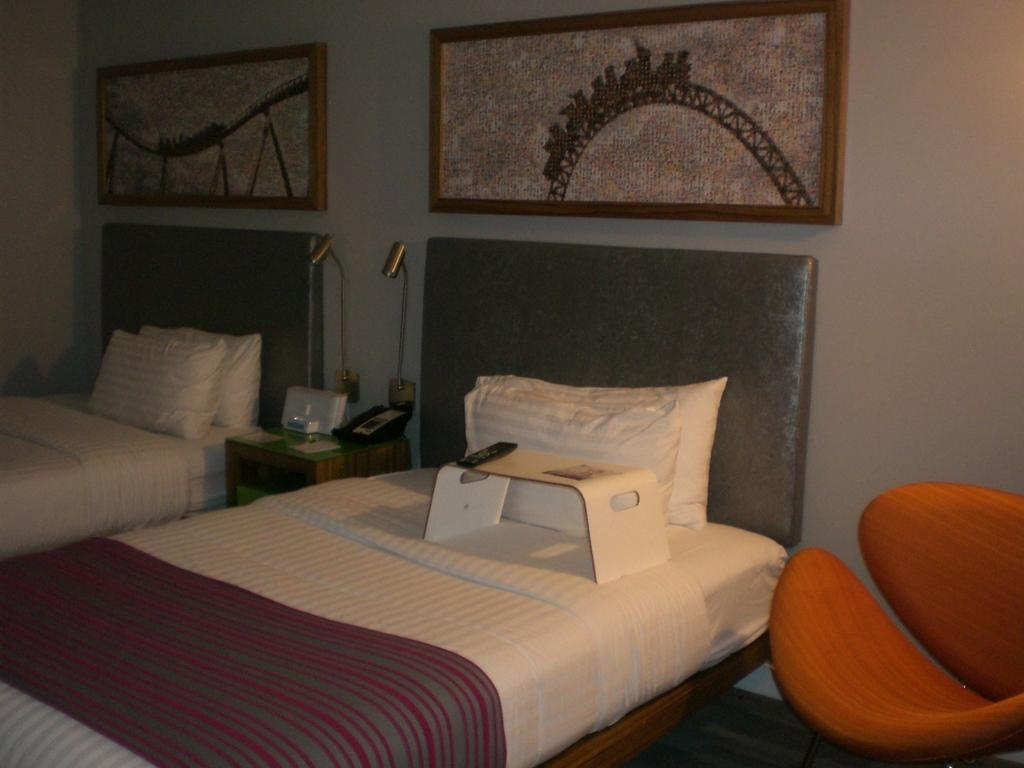Where was the image taken? The image was taken in a room. How many beds are in the room? There are two beds in the room. What can be found on the beds? There are pillows on the beds. What furniture is present in the room besides the beds? There is a desk and a couch in the room. What object is used for controlling electronic devices? There is a remote in the room. What type of lighting is available in the room? There are lamps in the room. What can be seen on the walls? There are frames on the wall. What other objects are present in the room? Various objects are present in the room. What songs are being sung by the snails on the point in the image? There are no snails or points present in the image, and therefore no songs can be heard. 